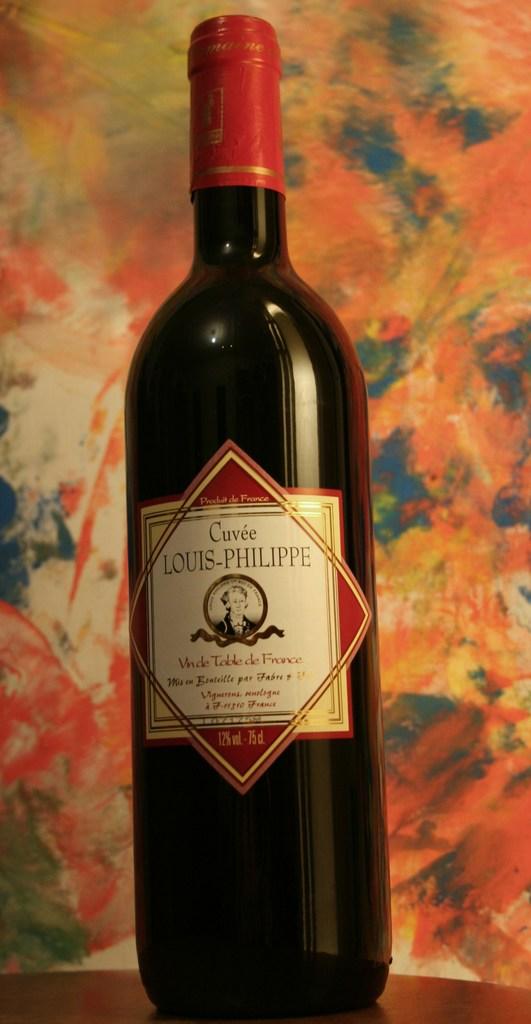What brand of wine is on the table?
Your response must be concise. Cuvee louis-philippe. What type of wine is this?
Your answer should be compact. Louis-philippe. 